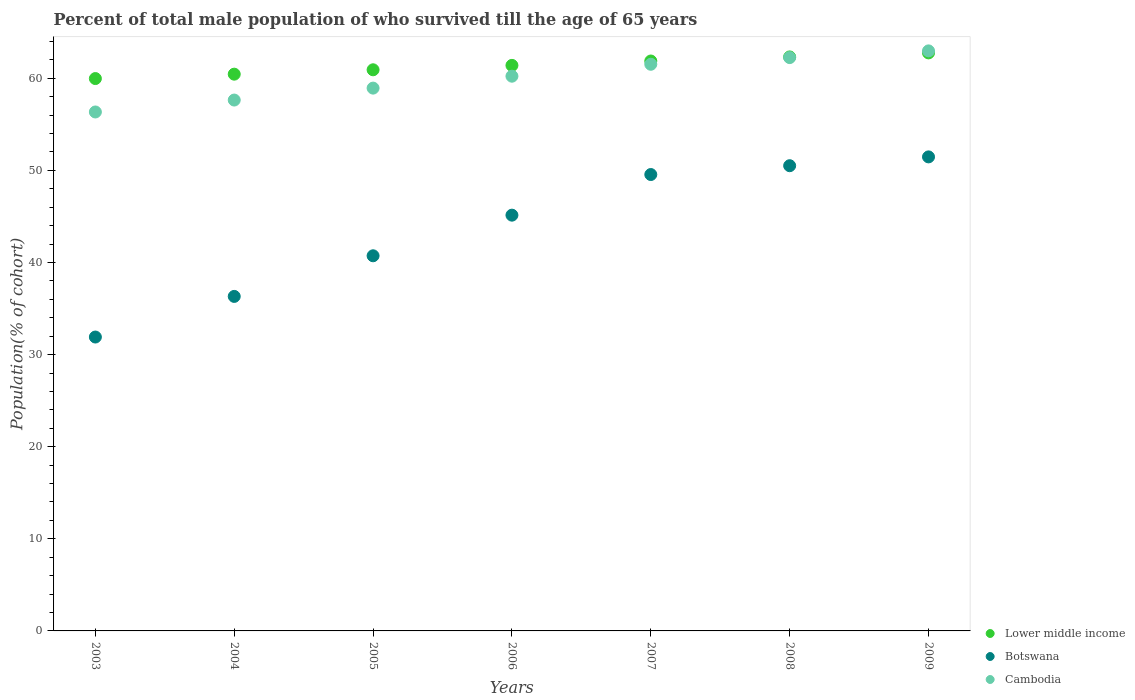How many different coloured dotlines are there?
Provide a succinct answer. 3. What is the percentage of total male population who survived till the age of 65 years in Lower middle income in 2006?
Provide a succinct answer. 61.4. Across all years, what is the maximum percentage of total male population who survived till the age of 65 years in Cambodia?
Your answer should be compact. 62.97. Across all years, what is the minimum percentage of total male population who survived till the age of 65 years in Cambodia?
Your response must be concise. 56.34. In which year was the percentage of total male population who survived till the age of 65 years in Cambodia maximum?
Provide a succinct answer. 2009. What is the total percentage of total male population who survived till the age of 65 years in Lower middle income in the graph?
Provide a succinct answer. 429.68. What is the difference between the percentage of total male population who survived till the age of 65 years in Cambodia in 2004 and that in 2005?
Offer a very short reply. -1.29. What is the difference between the percentage of total male population who survived till the age of 65 years in Cambodia in 2003 and the percentage of total male population who survived till the age of 65 years in Lower middle income in 2005?
Your answer should be compact. -4.58. What is the average percentage of total male population who survived till the age of 65 years in Cambodia per year?
Give a very brief answer. 59.98. In the year 2008, what is the difference between the percentage of total male population who survived till the age of 65 years in Lower middle income and percentage of total male population who survived till the age of 65 years in Botswana?
Provide a succinct answer. 11.81. What is the ratio of the percentage of total male population who survived till the age of 65 years in Botswana in 2005 to that in 2007?
Your answer should be compact. 0.82. What is the difference between the highest and the second highest percentage of total male population who survived till the age of 65 years in Cambodia?
Keep it short and to the point. 0.73. What is the difference between the highest and the lowest percentage of total male population who survived till the age of 65 years in Botswana?
Your response must be concise. 19.56. Is the sum of the percentage of total male population who survived till the age of 65 years in Cambodia in 2003 and 2004 greater than the maximum percentage of total male population who survived till the age of 65 years in Botswana across all years?
Keep it short and to the point. Yes. Is it the case that in every year, the sum of the percentage of total male population who survived till the age of 65 years in Lower middle income and percentage of total male population who survived till the age of 65 years in Botswana  is greater than the percentage of total male population who survived till the age of 65 years in Cambodia?
Provide a succinct answer. Yes. Does the percentage of total male population who survived till the age of 65 years in Cambodia monotonically increase over the years?
Ensure brevity in your answer.  Yes. Is the percentage of total male population who survived till the age of 65 years in Lower middle income strictly less than the percentage of total male population who survived till the age of 65 years in Botswana over the years?
Your answer should be very brief. No. What is the difference between two consecutive major ticks on the Y-axis?
Give a very brief answer. 10. Are the values on the major ticks of Y-axis written in scientific E-notation?
Ensure brevity in your answer.  No. Does the graph contain grids?
Give a very brief answer. No. How are the legend labels stacked?
Ensure brevity in your answer.  Vertical. What is the title of the graph?
Provide a short and direct response. Percent of total male population of who survived till the age of 65 years. Does "Malaysia" appear as one of the legend labels in the graph?
Give a very brief answer. No. What is the label or title of the Y-axis?
Keep it short and to the point. Population(% of cohort). What is the Population(% of cohort) of Lower middle income in 2003?
Keep it short and to the point. 59.97. What is the Population(% of cohort) in Botswana in 2003?
Your response must be concise. 31.91. What is the Population(% of cohort) in Cambodia in 2003?
Your answer should be very brief. 56.34. What is the Population(% of cohort) of Lower middle income in 2004?
Keep it short and to the point. 60.45. What is the Population(% of cohort) of Botswana in 2004?
Provide a short and direct response. 36.32. What is the Population(% of cohort) of Cambodia in 2004?
Your answer should be very brief. 57.64. What is the Population(% of cohort) of Lower middle income in 2005?
Your response must be concise. 60.92. What is the Population(% of cohort) of Botswana in 2005?
Provide a short and direct response. 40.73. What is the Population(% of cohort) of Cambodia in 2005?
Make the answer very short. 58.93. What is the Population(% of cohort) of Lower middle income in 2006?
Offer a terse response. 61.4. What is the Population(% of cohort) of Botswana in 2006?
Your answer should be compact. 45.14. What is the Population(% of cohort) in Cambodia in 2006?
Your answer should be very brief. 60.23. What is the Population(% of cohort) in Lower middle income in 2007?
Your answer should be very brief. 61.87. What is the Population(% of cohort) of Botswana in 2007?
Make the answer very short. 49.55. What is the Population(% of cohort) in Cambodia in 2007?
Give a very brief answer. 61.52. What is the Population(% of cohort) of Lower middle income in 2008?
Make the answer very short. 62.32. What is the Population(% of cohort) in Botswana in 2008?
Your answer should be very brief. 50.51. What is the Population(% of cohort) in Cambodia in 2008?
Your answer should be very brief. 62.25. What is the Population(% of cohort) in Lower middle income in 2009?
Offer a terse response. 62.76. What is the Population(% of cohort) of Botswana in 2009?
Give a very brief answer. 51.47. What is the Population(% of cohort) of Cambodia in 2009?
Provide a short and direct response. 62.97. Across all years, what is the maximum Population(% of cohort) in Lower middle income?
Make the answer very short. 62.76. Across all years, what is the maximum Population(% of cohort) in Botswana?
Offer a very short reply. 51.47. Across all years, what is the maximum Population(% of cohort) of Cambodia?
Provide a succinct answer. 62.97. Across all years, what is the minimum Population(% of cohort) in Lower middle income?
Your response must be concise. 59.97. Across all years, what is the minimum Population(% of cohort) of Botswana?
Your response must be concise. 31.91. Across all years, what is the minimum Population(% of cohort) in Cambodia?
Your answer should be compact. 56.34. What is the total Population(% of cohort) of Lower middle income in the graph?
Provide a short and direct response. 429.68. What is the total Population(% of cohort) of Botswana in the graph?
Your response must be concise. 305.61. What is the total Population(% of cohort) in Cambodia in the graph?
Provide a short and direct response. 419.88. What is the difference between the Population(% of cohort) of Lower middle income in 2003 and that in 2004?
Provide a succinct answer. -0.48. What is the difference between the Population(% of cohort) of Botswana in 2003 and that in 2004?
Make the answer very short. -4.41. What is the difference between the Population(% of cohort) in Cambodia in 2003 and that in 2004?
Provide a short and direct response. -1.29. What is the difference between the Population(% of cohort) in Lower middle income in 2003 and that in 2005?
Provide a succinct answer. -0.95. What is the difference between the Population(% of cohort) in Botswana in 2003 and that in 2005?
Keep it short and to the point. -8.82. What is the difference between the Population(% of cohort) in Cambodia in 2003 and that in 2005?
Give a very brief answer. -2.59. What is the difference between the Population(% of cohort) of Lower middle income in 2003 and that in 2006?
Your answer should be compact. -1.43. What is the difference between the Population(% of cohort) of Botswana in 2003 and that in 2006?
Offer a very short reply. -13.23. What is the difference between the Population(% of cohort) of Cambodia in 2003 and that in 2006?
Your answer should be very brief. -3.88. What is the difference between the Population(% of cohort) in Lower middle income in 2003 and that in 2007?
Offer a very short reply. -1.91. What is the difference between the Population(% of cohort) in Botswana in 2003 and that in 2007?
Your answer should be very brief. -17.64. What is the difference between the Population(% of cohort) in Cambodia in 2003 and that in 2007?
Provide a short and direct response. -5.18. What is the difference between the Population(% of cohort) of Lower middle income in 2003 and that in 2008?
Provide a short and direct response. -2.35. What is the difference between the Population(% of cohort) in Botswana in 2003 and that in 2008?
Offer a terse response. -18.6. What is the difference between the Population(% of cohort) of Cambodia in 2003 and that in 2008?
Give a very brief answer. -5.91. What is the difference between the Population(% of cohort) in Lower middle income in 2003 and that in 2009?
Your answer should be compact. -2.79. What is the difference between the Population(% of cohort) in Botswana in 2003 and that in 2009?
Ensure brevity in your answer.  -19.56. What is the difference between the Population(% of cohort) in Cambodia in 2003 and that in 2009?
Offer a very short reply. -6.63. What is the difference between the Population(% of cohort) of Lower middle income in 2004 and that in 2005?
Keep it short and to the point. -0.48. What is the difference between the Population(% of cohort) of Botswana in 2004 and that in 2005?
Offer a terse response. -4.41. What is the difference between the Population(% of cohort) in Cambodia in 2004 and that in 2005?
Provide a succinct answer. -1.29. What is the difference between the Population(% of cohort) of Lower middle income in 2004 and that in 2006?
Provide a succinct answer. -0.95. What is the difference between the Population(% of cohort) in Botswana in 2004 and that in 2006?
Your answer should be compact. -8.82. What is the difference between the Population(% of cohort) in Cambodia in 2004 and that in 2006?
Offer a very short reply. -2.59. What is the difference between the Population(% of cohort) of Lower middle income in 2004 and that in 2007?
Keep it short and to the point. -1.43. What is the difference between the Population(% of cohort) of Botswana in 2004 and that in 2007?
Give a very brief answer. -13.23. What is the difference between the Population(% of cohort) of Cambodia in 2004 and that in 2007?
Your answer should be very brief. -3.88. What is the difference between the Population(% of cohort) of Lower middle income in 2004 and that in 2008?
Your response must be concise. -1.87. What is the difference between the Population(% of cohort) of Botswana in 2004 and that in 2008?
Keep it short and to the point. -14.19. What is the difference between the Population(% of cohort) in Cambodia in 2004 and that in 2008?
Give a very brief answer. -4.61. What is the difference between the Population(% of cohort) in Lower middle income in 2004 and that in 2009?
Your response must be concise. -2.31. What is the difference between the Population(% of cohort) in Botswana in 2004 and that in 2009?
Your answer should be very brief. -15.15. What is the difference between the Population(% of cohort) of Cambodia in 2004 and that in 2009?
Your answer should be very brief. -5.34. What is the difference between the Population(% of cohort) in Lower middle income in 2005 and that in 2006?
Make the answer very short. -0.48. What is the difference between the Population(% of cohort) of Botswana in 2005 and that in 2006?
Provide a short and direct response. -4.41. What is the difference between the Population(% of cohort) in Cambodia in 2005 and that in 2006?
Provide a short and direct response. -1.29. What is the difference between the Population(% of cohort) of Lower middle income in 2005 and that in 2007?
Offer a terse response. -0.95. What is the difference between the Population(% of cohort) in Botswana in 2005 and that in 2007?
Give a very brief answer. -8.82. What is the difference between the Population(% of cohort) of Cambodia in 2005 and that in 2007?
Your answer should be compact. -2.59. What is the difference between the Population(% of cohort) of Lower middle income in 2005 and that in 2008?
Give a very brief answer. -1.4. What is the difference between the Population(% of cohort) of Botswana in 2005 and that in 2008?
Ensure brevity in your answer.  -9.78. What is the difference between the Population(% of cohort) in Cambodia in 2005 and that in 2008?
Give a very brief answer. -3.32. What is the difference between the Population(% of cohort) of Lower middle income in 2005 and that in 2009?
Keep it short and to the point. -1.84. What is the difference between the Population(% of cohort) in Botswana in 2005 and that in 2009?
Your answer should be very brief. -10.74. What is the difference between the Population(% of cohort) of Cambodia in 2005 and that in 2009?
Your answer should be very brief. -4.04. What is the difference between the Population(% of cohort) in Lower middle income in 2006 and that in 2007?
Give a very brief answer. -0.48. What is the difference between the Population(% of cohort) of Botswana in 2006 and that in 2007?
Provide a succinct answer. -4.41. What is the difference between the Population(% of cohort) in Cambodia in 2006 and that in 2007?
Offer a very short reply. -1.29. What is the difference between the Population(% of cohort) of Lower middle income in 2006 and that in 2008?
Your answer should be compact. -0.92. What is the difference between the Population(% of cohort) of Botswana in 2006 and that in 2008?
Keep it short and to the point. -5.37. What is the difference between the Population(% of cohort) of Cambodia in 2006 and that in 2008?
Ensure brevity in your answer.  -2.02. What is the difference between the Population(% of cohort) in Lower middle income in 2006 and that in 2009?
Offer a very short reply. -1.36. What is the difference between the Population(% of cohort) in Botswana in 2006 and that in 2009?
Your response must be concise. -6.33. What is the difference between the Population(% of cohort) in Cambodia in 2006 and that in 2009?
Make the answer very short. -2.75. What is the difference between the Population(% of cohort) in Lower middle income in 2007 and that in 2008?
Provide a short and direct response. -0.44. What is the difference between the Population(% of cohort) in Botswana in 2007 and that in 2008?
Your answer should be very brief. -0.96. What is the difference between the Population(% of cohort) of Cambodia in 2007 and that in 2008?
Make the answer very short. -0.73. What is the difference between the Population(% of cohort) of Lower middle income in 2007 and that in 2009?
Offer a terse response. -0.88. What is the difference between the Population(% of cohort) of Botswana in 2007 and that in 2009?
Your answer should be compact. -1.92. What is the difference between the Population(% of cohort) of Cambodia in 2007 and that in 2009?
Offer a terse response. -1.45. What is the difference between the Population(% of cohort) in Lower middle income in 2008 and that in 2009?
Make the answer very short. -0.44. What is the difference between the Population(% of cohort) in Botswana in 2008 and that in 2009?
Provide a short and direct response. -0.96. What is the difference between the Population(% of cohort) in Cambodia in 2008 and that in 2009?
Your response must be concise. -0.73. What is the difference between the Population(% of cohort) in Lower middle income in 2003 and the Population(% of cohort) in Botswana in 2004?
Your answer should be compact. 23.65. What is the difference between the Population(% of cohort) of Lower middle income in 2003 and the Population(% of cohort) of Cambodia in 2004?
Your answer should be very brief. 2.33. What is the difference between the Population(% of cohort) of Botswana in 2003 and the Population(% of cohort) of Cambodia in 2004?
Give a very brief answer. -25.73. What is the difference between the Population(% of cohort) in Lower middle income in 2003 and the Population(% of cohort) in Botswana in 2005?
Provide a succinct answer. 19.24. What is the difference between the Population(% of cohort) of Lower middle income in 2003 and the Population(% of cohort) of Cambodia in 2005?
Your answer should be compact. 1.04. What is the difference between the Population(% of cohort) in Botswana in 2003 and the Population(% of cohort) in Cambodia in 2005?
Offer a very short reply. -27.02. What is the difference between the Population(% of cohort) in Lower middle income in 2003 and the Population(% of cohort) in Botswana in 2006?
Keep it short and to the point. 14.83. What is the difference between the Population(% of cohort) of Lower middle income in 2003 and the Population(% of cohort) of Cambodia in 2006?
Your response must be concise. -0.26. What is the difference between the Population(% of cohort) in Botswana in 2003 and the Population(% of cohort) in Cambodia in 2006?
Keep it short and to the point. -28.32. What is the difference between the Population(% of cohort) of Lower middle income in 2003 and the Population(% of cohort) of Botswana in 2007?
Offer a very short reply. 10.42. What is the difference between the Population(% of cohort) in Lower middle income in 2003 and the Population(% of cohort) in Cambodia in 2007?
Ensure brevity in your answer.  -1.55. What is the difference between the Population(% of cohort) of Botswana in 2003 and the Population(% of cohort) of Cambodia in 2007?
Provide a succinct answer. -29.61. What is the difference between the Population(% of cohort) in Lower middle income in 2003 and the Population(% of cohort) in Botswana in 2008?
Your answer should be compact. 9.46. What is the difference between the Population(% of cohort) of Lower middle income in 2003 and the Population(% of cohort) of Cambodia in 2008?
Your response must be concise. -2.28. What is the difference between the Population(% of cohort) in Botswana in 2003 and the Population(% of cohort) in Cambodia in 2008?
Give a very brief answer. -30.34. What is the difference between the Population(% of cohort) in Lower middle income in 2003 and the Population(% of cohort) in Botswana in 2009?
Provide a short and direct response. 8.5. What is the difference between the Population(% of cohort) of Lower middle income in 2003 and the Population(% of cohort) of Cambodia in 2009?
Make the answer very short. -3. What is the difference between the Population(% of cohort) in Botswana in 2003 and the Population(% of cohort) in Cambodia in 2009?
Keep it short and to the point. -31.07. What is the difference between the Population(% of cohort) in Lower middle income in 2004 and the Population(% of cohort) in Botswana in 2005?
Offer a terse response. 19.72. What is the difference between the Population(% of cohort) of Lower middle income in 2004 and the Population(% of cohort) of Cambodia in 2005?
Your answer should be compact. 1.51. What is the difference between the Population(% of cohort) in Botswana in 2004 and the Population(% of cohort) in Cambodia in 2005?
Provide a succinct answer. -22.61. What is the difference between the Population(% of cohort) in Lower middle income in 2004 and the Population(% of cohort) in Botswana in 2006?
Make the answer very short. 15.31. What is the difference between the Population(% of cohort) in Lower middle income in 2004 and the Population(% of cohort) in Cambodia in 2006?
Give a very brief answer. 0.22. What is the difference between the Population(% of cohort) of Botswana in 2004 and the Population(% of cohort) of Cambodia in 2006?
Ensure brevity in your answer.  -23.91. What is the difference between the Population(% of cohort) of Lower middle income in 2004 and the Population(% of cohort) of Botswana in 2007?
Give a very brief answer. 10.9. What is the difference between the Population(% of cohort) in Lower middle income in 2004 and the Population(% of cohort) in Cambodia in 2007?
Your answer should be very brief. -1.07. What is the difference between the Population(% of cohort) in Botswana in 2004 and the Population(% of cohort) in Cambodia in 2007?
Ensure brevity in your answer.  -25.2. What is the difference between the Population(% of cohort) in Lower middle income in 2004 and the Population(% of cohort) in Botswana in 2008?
Provide a short and direct response. 9.94. What is the difference between the Population(% of cohort) of Lower middle income in 2004 and the Population(% of cohort) of Cambodia in 2008?
Your response must be concise. -1.8. What is the difference between the Population(% of cohort) in Botswana in 2004 and the Population(% of cohort) in Cambodia in 2008?
Provide a short and direct response. -25.93. What is the difference between the Population(% of cohort) of Lower middle income in 2004 and the Population(% of cohort) of Botswana in 2009?
Provide a succinct answer. 8.98. What is the difference between the Population(% of cohort) of Lower middle income in 2004 and the Population(% of cohort) of Cambodia in 2009?
Offer a very short reply. -2.53. What is the difference between the Population(% of cohort) of Botswana in 2004 and the Population(% of cohort) of Cambodia in 2009?
Ensure brevity in your answer.  -26.66. What is the difference between the Population(% of cohort) of Lower middle income in 2005 and the Population(% of cohort) of Botswana in 2006?
Your answer should be very brief. 15.78. What is the difference between the Population(% of cohort) of Lower middle income in 2005 and the Population(% of cohort) of Cambodia in 2006?
Give a very brief answer. 0.7. What is the difference between the Population(% of cohort) in Botswana in 2005 and the Population(% of cohort) in Cambodia in 2006?
Your response must be concise. -19.5. What is the difference between the Population(% of cohort) in Lower middle income in 2005 and the Population(% of cohort) in Botswana in 2007?
Offer a terse response. 11.37. What is the difference between the Population(% of cohort) of Lower middle income in 2005 and the Population(% of cohort) of Cambodia in 2007?
Ensure brevity in your answer.  -0.6. What is the difference between the Population(% of cohort) of Botswana in 2005 and the Population(% of cohort) of Cambodia in 2007?
Your answer should be very brief. -20.79. What is the difference between the Population(% of cohort) of Lower middle income in 2005 and the Population(% of cohort) of Botswana in 2008?
Give a very brief answer. 10.41. What is the difference between the Population(% of cohort) in Lower middle income in 2005 and the Population(% of cohort) in Cambodia in 2008?
Offer a terse response. -1.33. What is the difference between the Population(% of cohort) of Botswana in 2005 and the Population(% of cohort) of Cambodia in 2008?
Offer a terse response. -21.52. What is the difference between the Population(% of cohort) of Lower middle income in 2005 and the Population(% of cohort) of Botswana in 2009?
Your response must be concise. 9.46. What is the difference between the Population(% of cohort) of Lower middle income in 2005 and the Population(% of cohort) of Cambodia in 2009?
Your answer should be very brief. -2.05. What is the difference between the Population(% of cohort) of Botswana in 2005 and the Population(% of cohort) of Cambodia in 2009?
Provide a short and direct response. -22.25. What is the difference between the Population(% of cohort) of Lower middle income in 2006 and the Population(% of cohort) of Botswana in 2007?
Keep it short and to the point. 11.85. What is the difference between the Population(% of cohort) of Lower middle income in 2006 and the Population(% of cohort) of Cambodia in 2007?
Your answer should be very brief. -0.12. What is the difference between the Population(% of cohort) of Botswana in 2006 and the Population(% of cohort) of Cambodia in 2007?
Give a very brief answer. -16.38. What is the difference between the Population(% of cohort) of Lower middle income in 2006 and the Population(% of cohort) of Botswana in 2008?
Offer a terse response. 10.89. What is the difference between the Population(% of cohort) of Lower middle income in 2006 and the Population(% of cohort) of Cambodia in 2008?
Offer a terse response. -0.85. What is the difference between the Population(% of cohort) in Botswana in 2006 and the Population(% of cohort) in Cambodia in 2008?
Make the answer very short. -17.11. What is the difference between the Population(% of cohort) in Lower middle income in 2006 and the Population(% of cohort) in Botswana in 2009?
Provide a succinct answer. 9.93. What is the difference between the Population(% of cohort) in Lower middle income in 2006 and the Population(% of cohort) in Cambodia in 2009?
Offer a very short reply. -1.57. What is the difference between the Population(% of cohort) of Botswana in 2006 and the Population(% of cohort) of Cambodia in 2009?
Provide a short and direct response. -17.83. What is the difference between the Population(% of cohort) in Lower middle income in 2007 and the Population(% of cohort) in Botswana in 2008?
Your answer should be compact. 11.37. What is the difference between the Population(% of cohort) in Lower middle income in 2007 and the Population(% of cohort) in Cambodia in 2008?
Provide a short and direct response. -0.37. What is the difference between the Population(% of cohort) of Botswana in 2007 and the Population(% of cohort) of Cambodia in 2008?
Your answer should be compact. -12.7. What is the difference between the Population(% of cohort) in Lower middle income in 2007 and the Population(% of cohort) in Botswana in 2009?
Your answer should be compact. 10.41. What is the difference between the Population(% of cohort) of Lower middle income in 2007 and the Population(% of cohort) of Cambodia in 2009?
Your response must be concise. -1.1. What is the difference between the Population(% of cohort) of Botswana in 2007 and the Population(% of cohort) of Cambodia in 2009?
Offer a very short reply. -13.42. What is the difference between the Population(% of cohort) of Lower middle income in 2008 and the Population(% of cohort) of Botswana in 2009?
Your response must be concise. 10.85. What is the difference between the Population(% of cohort) in Lower middle income in 2008 and the Population(% of cohort) in Cambodia in 2009?
Keep it short and to the point. -0.66. What is the difference between the Population(% of cohort) in Botswana in 2008 and the Population(% of cohort) in Cambodia in 2009?
Your answer should be compact. -12.47. What is the average Population(% of cohort) in Lower middle income per year?
Your answer should be compact. 61.38. What is the average Population(% of cohort) of Botswana per year?
Offer a terse response. 43.66. What is the average Population(% of cohort) in Cambodia per year?
Provide a succinct answer. 59.98. In the year 2003, what is the difference between the Population(% of cohort) of Lower middle income and Population(% of cohort) of Botswana?
Make the answer very short. 28.06. In the year 2003, what is the difference between the Population(% of cohort) in Lower middle income and Population(% of cohort) in Cambodia?
Your answer should be compact. 3.63. In the year 2003, what is the difference between the Population(% of cohort) of Botswana and Population(% of cohort) of Cambodia?
Keep it short and to the point. -24.43. In the year 2004, what is the difference between the Population(% of cohort) of Lower middle income and Population(% of cohort) of Botswana?
Offer a terse response. 24.13. In the year 2004, what is the difference between the Population(% of cohort) of Lower middle income and Population(% of cohort) of Cambodia?
Provide a succinct answer. 2.81. In the year 2004, what is the difference between the Population(% of cohort) in Botswana and Population(% of cohort) in Cambodia?
Give a very brief answer. -21.32. In the year 2005, what is the difference between the Population(% of cohort) of Lower middle income and Population(% of cohort) of Botswana?
Your answer should be compact. 20.19. In the year 2005, what is the difference between the Population(% of cohort) of Lower middle income and Population(% of cohort) of Cambodia?
Provide a succinct answer. 1.99. In the year 2005, what is the difference between the Population(% of cohort) in Botswana and Population(% of cohort) in Cambodia?
Your answer should be compact. -18.2. In the year 2006, what is the difference between the Population(% of cohort) of Lower middle income and Population(% of cohort) of Botswana?
Offer a very short reply. 16.26. In the year 2006, what is the difference between the Population(% of cohort) in Lower middle income and Population(% of cohort) in Cambodia?
Make the answer very short. 1.17. In the year 2006, what is the difference between the Population(% of cohort) of Botswana and Population(% of cohort) of Cambodia?
Your answer should be very brief. -15.09. In the year 2007, what is the difference between the Population(% of cohort) in Lower middle income and Population(% of cohort) in Botswana?
Ensure brevity in your answer.  12.32. In the year 2007, what is the difference between the Population(% of cohort) of Lower middle income and Population(% of cohort) of Cambodia?
Ensure brevity in your answer.  0.35. In the year 2007, what is the difference between the Population(% of cohort) of Botswana and Population(% of cohort) of Cambodia?
Offer a very short reply. -11.97. In the year 2008, what is the difference between the Population(% of cohort) of Lower middle income and Population(% of cohort) of Botswana?
Your response must be concise. 11.81. In the year 2008, what is the difference between the Population(% of cohort) in Lower middle income and Population(% of cohort) in Cambodia?
Make the answer very short. 0.07. In the year 2008, what is the difference between the Population(% of cohort) in Botswana and Population(% of cohort) in Cambodia?
Provide a short and direct response. -11.74. In the year 2009, what is the difference between the Population(% of cohort) in Lower middle income and Population(% of cohort) in Botswana?
Make the answer very short. 11.29. In the year 2009, what is the difference between the Population(% of cohort) of Lower middle income and Population(% of cohort) of Cambodia?
Give a very brief answer. -0.22. In the year 2009, what is the difference between the Population(% of cohort) of Botswana and Population(% of cohort) of Cambodia?
Keep it short and to the point. -11.51. What is the ratio of the Population(% of cohort) of Lower middle income in 2003 to that in 2004?
Provide a short and direct response. 0.99. What is the ratio of the Population(% of cohort) of Botswana in 2003 to that in 2004?
Your answer should be very brief. 0.88. What is the ratio of the Population(% of cohort) in Cambodia in 2003 to that in 2004?
Keep it short and to the point. 0.98. What is the ratio of the Population(% of cohort) in Lower middle income in 2003 to that in 2005?
Provide a short and direct response. 0.98. What is the ratio of the Population(% of cohort) in Botswana in 2003 to that in 2005?
Your answer should be very brief. 0.78. What is the ratio of the Population(% of cohort) in Cambodia in 2003 to that in 2005?
Provide a short and direct response. 0.96. What is the ratio of the Population(% of cohort) in Lower middle income in 2003 to that in 2006?
Provide a short and direct response. 0.98. What is the ratio of the Population(% of cohort) of Botswana in 2003 to that in 2006?
Give a very brief answer. 0.71. What is the ratio of the Population(% of cohort) in Cambodia in 2003 to that in 2006?
Make the answer very short. 0.94. What is the ratio of the Population(% of cohort) of Lower middle income in 2003 to that in 2007?
Your response must be concise. 0.97. What is the ratio of the Population(% of cohort) of Botswana in 2003 to that in 2007?
Offer a terse response. 0.64. What is the ratio of the Population(% of cohort) of Cambodia in 2003 to that in 2007?
Your answer should be compact. 0.92. What is the ratio of the Population(% of cohort) of Lower middle income in 2003 to that in 2008?
Offer a very short reply. 0.96. What is the ratio of the Population(% of cohort) of Botswana in 2003 to that in 2008?
Give a very brief answer. 0.63. What is the ratio of the Population(% of cohort) of Cambodia in 2003 to that in 2008?
Your answer should be very brief. 0.91. What is the ratio of the Population(% of cohort) in Lower middle income in 2003 to that in 2009?
Your answer should be very brief. 0.96. What is the ratio of the Population(% of cohort) of Botswana in 2003 to that in 2009?
Offer a very short reply. 0.62. What is the ratio of the Population(% of cohort) of Cambodia in 2003 to that in 2009?
Give a very brief answer. 0.89. What is the ratio of the Population(% of cohort) of Lower middle income in 2004 to that in 2005?
Give a very brief answer. 0.99. What is the ratio of the Population(% of cohort) in Botswana in 2004 to that in 2005?
Provide a succinct answer. 0.89. What is the ratio of the Population(% of cohort) in Lower middle income in 2004 to that in 2006?
Offer a very short reply. 0.98. What is the ratio of the Population(% of cohort) in Botswana in 2004 to that in 2006?
Give a very brief answer. 0.8. What is the ratio of the Population(% of cohort) of Lower middle income in 2004 to that in 2007?
Keep it short and to the point. 0.98. What is the ratio of the Population(% of cohort) in Botswana in 2004 to that in 2007?
Offer a terse response. 0.73. What is the ratio of the Population(% of cohort) of Cambodia in 2004 to that in 2007?
Offer a very short reply. 0.94. What is the ratio of the Population(% of cohort) in Botswana in 2004 to that in 2008?
Offer a terse response. 0.72. What is the ratio of the Population(% of cohort) of Cambodia in 2004 to that in 2008?
Make the answer very short. 0.93. What is the ratio of the Population(% of cohort) of Lower middle income in 2004 to that in 2009?
Keep it short and to the point. 0.96. What is the ratio of the Population(% of cohort) of Botswana in 2004 to that in 2009?
Offer a very short reply. 0.71. What is the ratio of the Population(% of cohort) in Cambodia in 2004 to that in 2009?
Your answer should be compact. 0.92. What is the ratio of the Population(% of cohort) in Lower middle income in 2005 to that in 2006?
Your answer should be compact. 0.99. What is the ratio of the Population(% of cohort) in Botswana in 2005 to that in 2006?
Your answer should be very brief. 0.9. What is the ratio of the Population(% of cohort) of Cambodia in 2005 to that in 2006?
Offer a very short reply. 0.98. What is the ratio of the Population(% of cohort) in Lower middle income in 2005 to that in 2007?
Offer a terse response. 0.98. What is the ratio of the Population(% of cohort) of Botswana in 2005 to that in 2007?
Keep it short and to the point. 0.82. What is the ratio of the Population(% of cohort) of Cambodia in 2005 to that in 2007?
Offer a terse response. 0.96. What is the ratio of the Population(% of cohort) of Lower middle income in 2005 to that in 2008?
Make the answer very short. 0.98. What is the ratio of the Population(% of cohort) of Botswana in 2005 to that in 2008?
Offer a terse response. 0.81. What is the ratio of the Population(% of cohort) in Cambodia in 2005 to that in 2008?
Ensure brevity in your answer.  0.95. What is the ratio of the Population(% of cohort) of Lower middle income in 2005 to that in 2009?
Offer a terse response. 0.97. What is the ratio of the Population(% of cohort) in Botswana in 2005 to that in 2009?
Your answer should be compact. 0.79. What is the ratio of the Population(% of cohort) in Cambodia in 2005 to that in 2009?
Your answer should be compact. 0.94. What is the ratio of the Population(% of cohort) in Botswana in 2006 to that in 2007?
Offer a very short reply. 0.91. What is the ratio of the Population(% of cohort) of Botswana in 2006 to that in 2008?
Offer a very short reply. 0.89. What is the ratio of the Population(% of cohort) in Cambodia in 2006 to that in 2008?
Offer a very short reply. 0.97. What is the ratio of the Population(% of cohort) in Lower middle income in 2006 to that in 2009?
Your answer should be compact. 0.98. What is the ratio of the Population(% of cohort) in Botswana in 2006 to that in 2009?
Provide a short and direct response. 0.88. What is the ratio of the Population(% of cohort) of Cambodia in 2006 to that in 2009?
Provide a short and direct response. 0.96. What is the ratio of the Population(% of cohort) of Lower middle income in 2007 to that in 2008?
Provide a short and direct response. 0.99. What is the ratio of the Population(% of cohort) in Botswana in 2007 to that in 2008?
Your response must be concise. 0.98. What is the ratio of the Population(% of cohort) of Cambodia in 2007 to that in 2008?
Offer a very short reply. 0.99. What is the ratio of the Population(% of cohort) in Lower middle income in 2007 to that in 2009?
Provide a short and direct response. 0.99. What is the ratio of the Population(% of cohort) of Botswana in 2007 to that in 2009?
Ensure brevity in your answer.  0.96. What is the ratio of the Population(% of cohort) in Cambodia in 2007 to that in 2009?
Your answer should be compact. 0.98. What is the ratio of the Population(% of cohort) of Lower middle income in 2008 to that in 2009?
Offer a very short reply. 0.99. What is the ratio of the Population(% of cohort) of Botswana in 2008 to that in 2009?
Your answer should be very brief. 0.98. What is the ratio of the Population(% of cohort) in Cambodia in 2008 to that in 2009?
Keep it short and to the point. 0.99. What is the difference between the highest and the second highest Population(% of cohort) in Lower middle income?
Offer a terse response. 0.44. What is the difference between the highest and the second highest Population(% of cohort) in Botswana?
Give a very brief answer. 0.96. What is the difference between the highest and the second highest Population(% of cohort) in Cambodia?
Ensure brevity in your answer.  0.73. What is the difference between the highest and the lowest Population(% of cohort) in Lower middle income?
Provide a succinct answer. 2.79. What is the difference between the highest and the lowest Population(% of cohort) of Botswana?
Ensure brevity in your answer.  19.56. What is the difference between the highest and the lowest Population(% of cohort) in Cambodia?
Your answer should be compact. 6.63. 